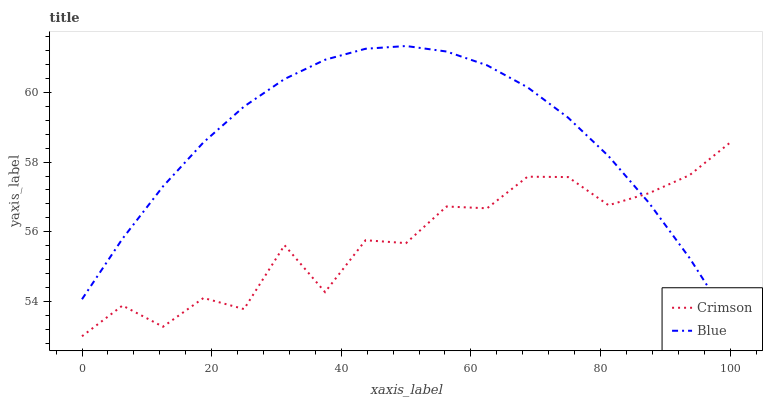Does Crimson have the minimum area under the curve?
Answer yes or no. Yes. Does Blue have the maximum area under the curve?
Answer yes or no. Yes. Does Blue have the minimum area under the curve?
Answer yes or no. No. Is Blue the smoothest?
Answer yes or no. Yes. Is Crimson the roughest?
Answer yes or no. Yes. Is Blue the roughest?
Answer yes or no. No. Does Blue have the lowest value?
Answer yes or no. No. 